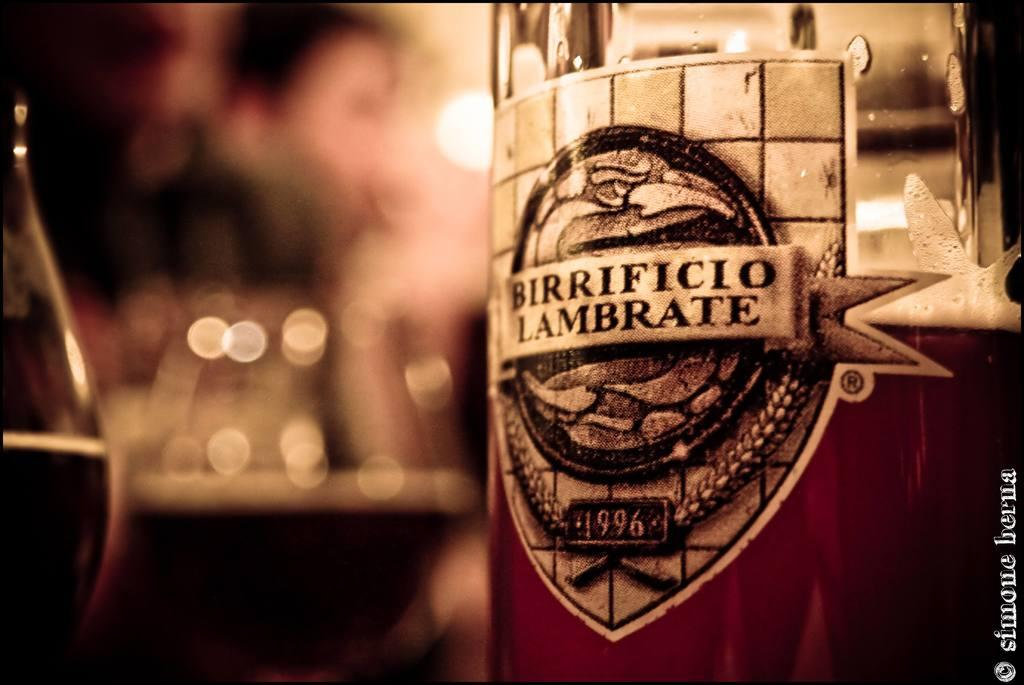<image>
Render a clear and concise summary of the photo. A close up of the label on a bottle of Birrificio Lambrate 1996 